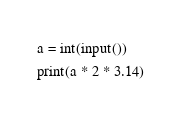Convert code to text. <code><loc_0><loc_0><loc_500><loc_500><_Python_>a = int(input())
print(a * 2 * 3.14)</code> 